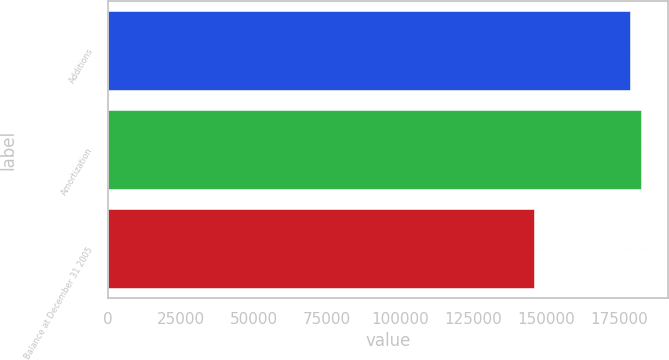Convert chart to OTSL. <chart><loc_0><loc_0><loc_500><loc_500><bar_chart><fcel>Additions<fcel>Amortization<fcel>Balance at December 31 2005<nl><fcel>178788<fcel>182534<fcel>145612<nl></chart> 